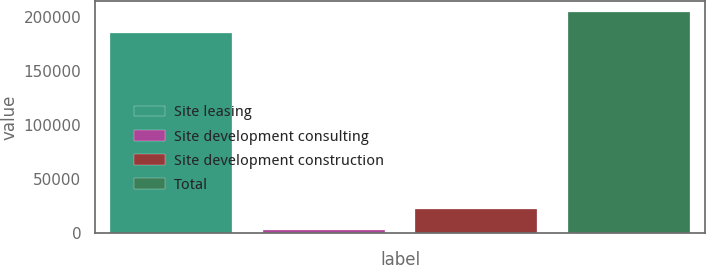Convert chart to OTSL. <chart><loc_0><loc_0><loc_500><loc_500><bar_chart><fcel>Site leasing<fcel>Site development consulting<fcel>Site development construction<fcel>Total<nl><fcel>185507<fcel>2578<fcel>21771.8<fcel>204701<nl></chart> 